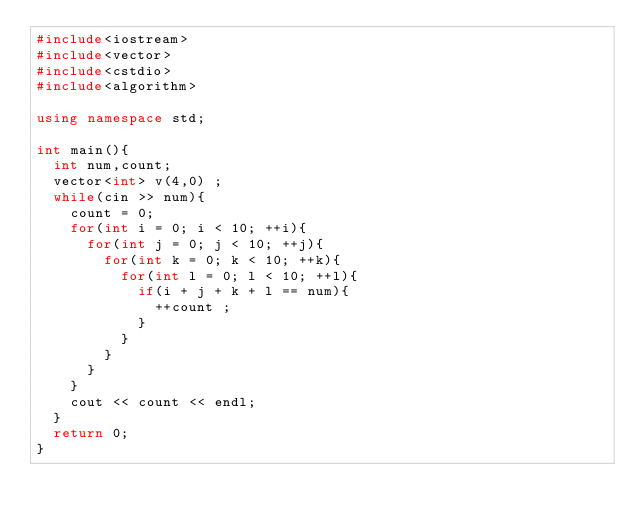<code> <loc_0><loc_0><loc_500><loc_500><_C++_>#include<iostream>
#include<vector>
#include<cstdio>
#include<algorithm>

using namespace std;

int main(){
  int num,count;
  vector<int> v(4,0) ;
  while(cin >> num){
    count = 0;
    for(int i = 0; i < 10; ++i){
      for(int j = 0; j < 10; ++j){
        for(int k = 0; k < 10; ++k){
          for(int l = 0; l < 10; ++l){
            if(i + j + k + l == num){
              ++count ;
            }
          }
        }
      }
    }
    cout << count << endl;
  }
  return 0;
}</code> 